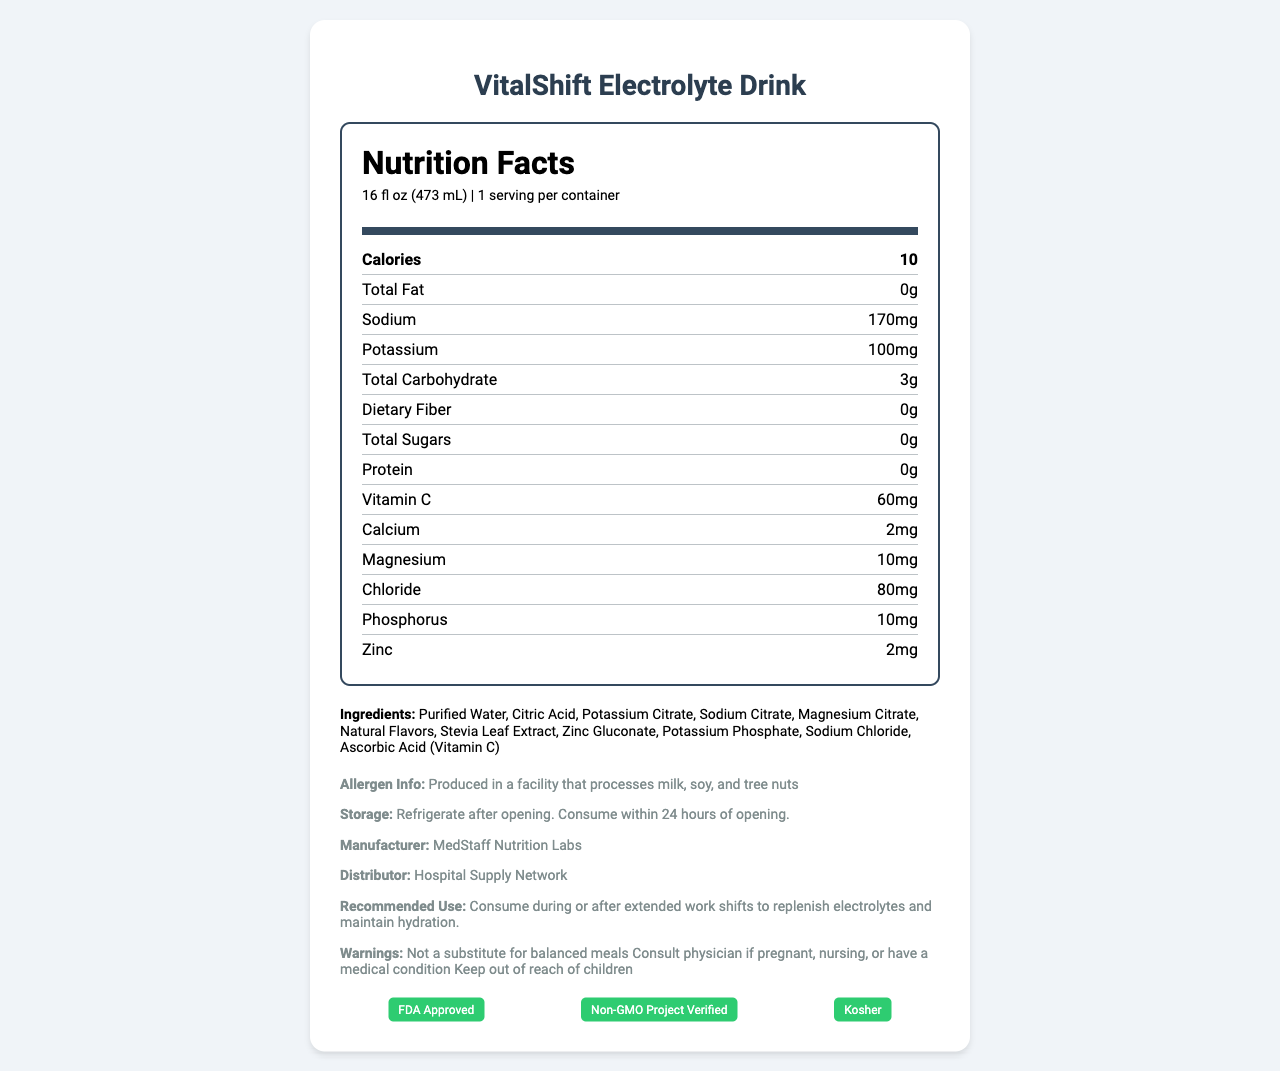what is the serving size? The serving size is specified in the Nutrition Facts section next to the serving information.
Answer: 16 fl oz (473 mL) How many calories are in one serving of the VitalShift Electrolyte Drink? The calories per serving are listed under the "Calories" section in the Nutrition Facts.
Answer: 10 What is the amount of total fat per serving? The total fat amount per serving is shown in the Nutrition Facts section.
Answer: 0g How much sodium is in the VitalShift Electrolyte Drink? The sodium content per serving is displayed in the Nutrition Facts section.
Answer: 170mg List three ingredients found in the VitalShift Electrolyte Drink. The ingredients list contains these as the first three items.
Answer: Purified Water, Citric Acid, Potassium Citrate Is VitalShift Electrolyte Drink sugar-free? The total sugars are listed as 0g in the Nutrition Facts section.
Answer: Yes Which of the following is not listed as an ingredient in the VitalShift Electrolyte Drink?
A. Stevia Leaf Extract
B. Gluten
C. Magnesium Citrate The ingredient list includes Stevia Leaf Extract and Magnesium Citrate but not Gluten.
Answer: B What certification does the VitalShift Electrolyte Drink have?
A. FDA Approved
B. Organic
C. Halal The document lists the "FDA Approved" certification among others.
Answer: A Does the VitalShift Electrolyte Drink offer any dietary fiber? The Nutrition Facts section indicates 0g of dietary fiber.
Answer: No Summarize the main purpose of the VitalShift Electrolyte Drink. The document highlights its formulation for medical professionals, benefits of electrolyte balance, sugar-free energy support, and immune function enhancement, covering these points in the additional information and recommendations.
Answer: The VitalShift Electrolyte Drink is specially formulated for medical professionals working extended shifts to help maintain electrolyte balance, support sustained energy levels, and enhance immune function without added sugars. What is the potassium content per serving? The potassium content is displayed under the nutrient content information.
Answer: 100mg Can the exact price of the VitalShift Electrolyte Drink be found in the document? The document does not provide any information about the price of the drink.
Answer: Cannot be determined What additional recommendation is given regarding the use of the VitalShift Electrolyte Drink? This specific recommendation is found in the "recommended use" section of the document.
Answer: Consume during or after extended work shifts to replenish electrolytes and maintain hydration. Does the VitalShift Electrolyte Drink contain any allergens? The allergen information indicates that it is produced in a facility that processes these allergens.
Answer: Produced in a facility that processes milk, soy, and tree nuts What benefit does Vitamin C provide in the drink according to the document? The additional info section mentions that Vitamin C is added to support immune function.
Answer: Supports immune function 